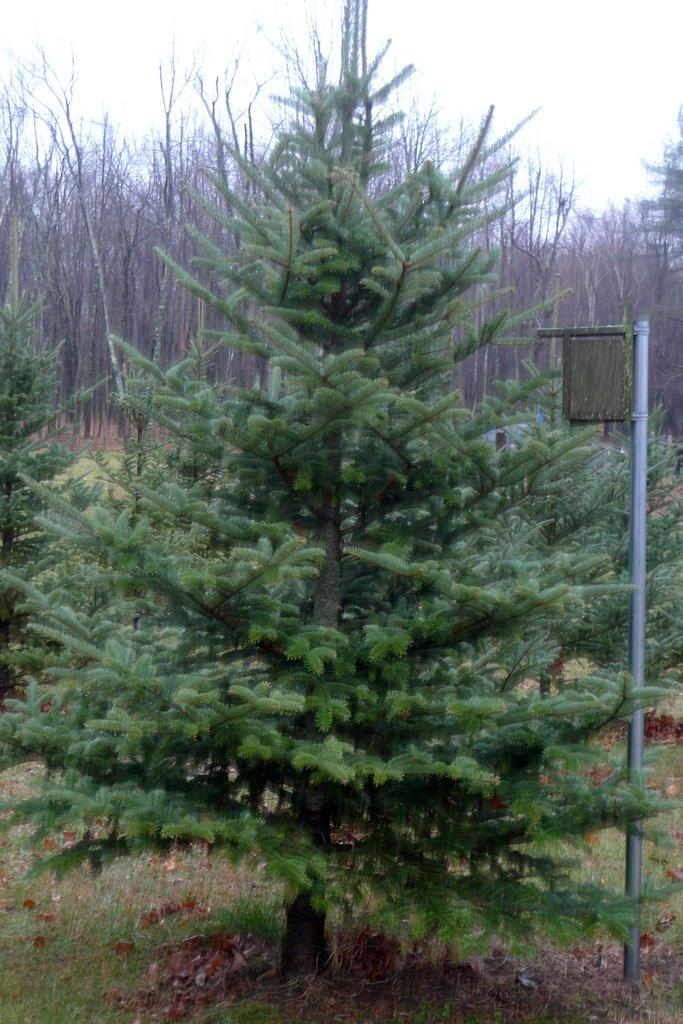What type of vegetation can be seen in the image? There is a group of trees and grass in the image. What else is present in the image besides vegetation? There is a pole in the image. What can be seen in the sky in the image? The sky is visible in the image. How many ducks are sitting on the pole in the image? There are no ducks present in the image, and therefore no ducks are sitting on the pole. What type of dog can be seen playing with the grass in the image? There is no dog present in the image, and therefore no dog is playing with the grass. 